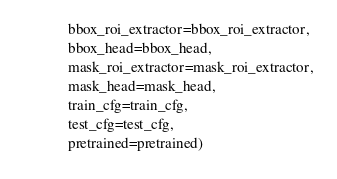Convert code to text. <code><loc_0><loc_0><loc_500><loc_500><_Python_>            bbox_roi_extractor=bbox_roi_extractor,
            bbox_head=bbox_head,
            mask_roi_extractor=mask_roi_extractor,
            mask_head=mask_head,
            train_cfg=train_cfg,
            test_cfg=test_cfg,
            pretrained=pretrained)
</code> 